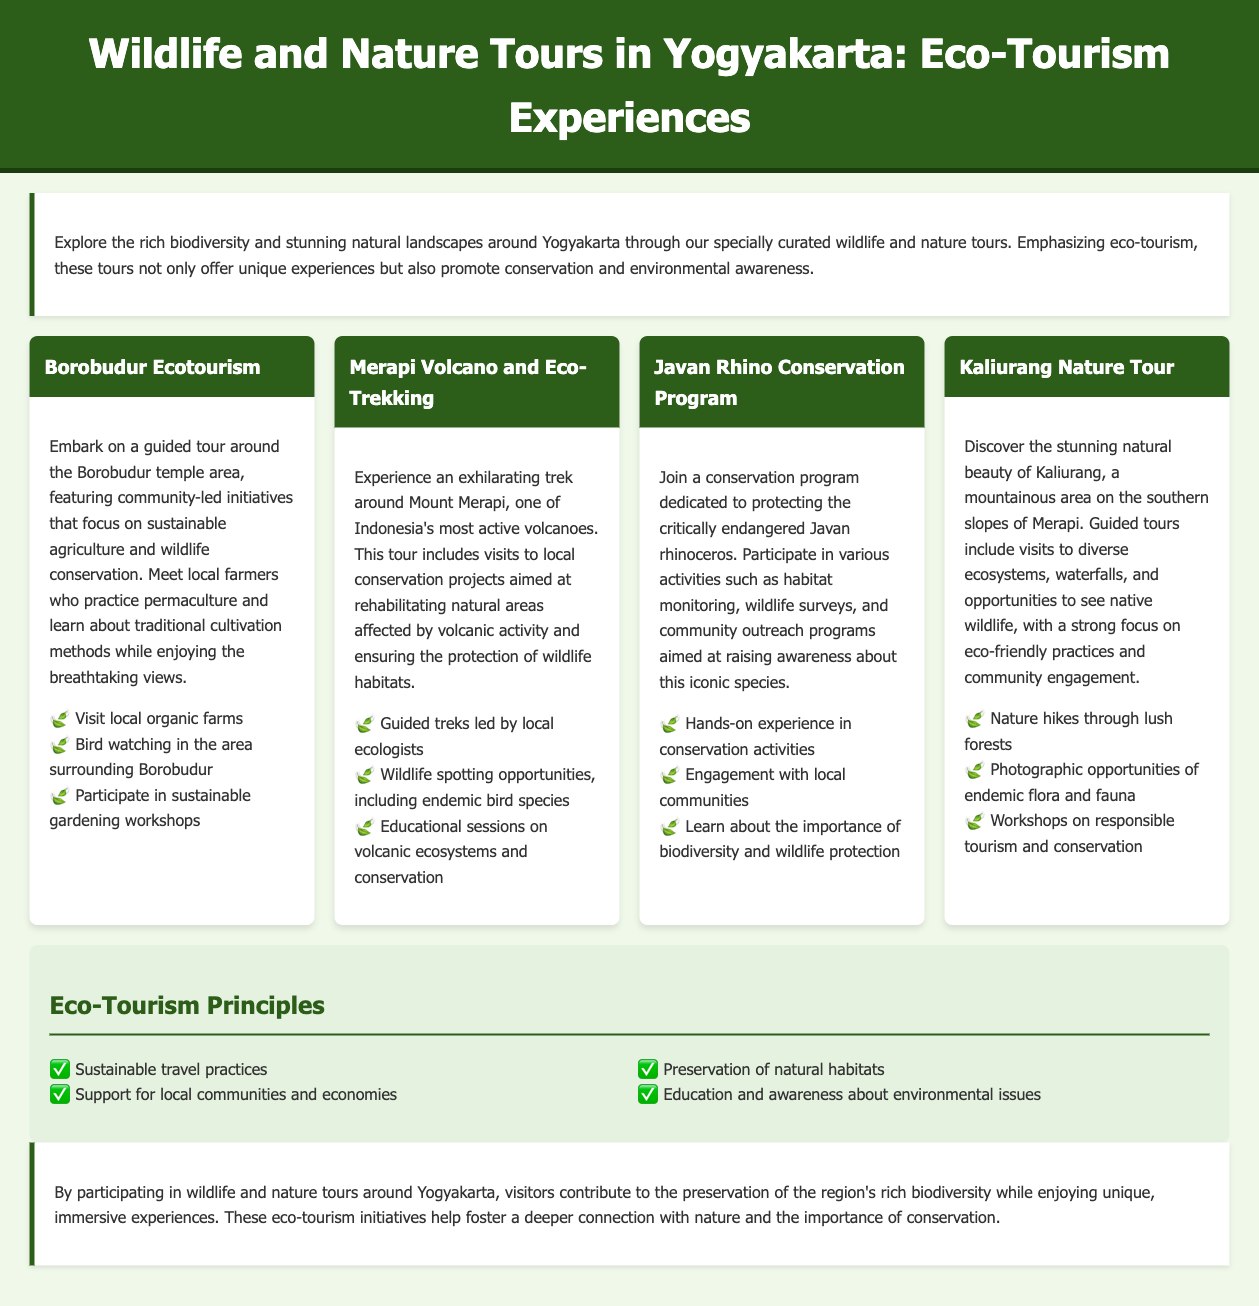What is the title of the document? The title of the document is found in the head section of the HTML code as specified in the title tag.
Answer: Wildlife and Nature Tours in Yogyakarta: Eco-Tourism Experiences How many tours are listed in the document? The tours can be counted in the tour-grid section, where each tour is represented by a tour card.
Answer: 4 What is the main focus of the tours? The main focus is highlighted in the introduction at the beginning of the document, emphasizing eco-tourism.
Answer: Eco-tourism Which volcano is featured in one of the tours? The specific volcano can be identified in the title of the tour that includes it.
Answer: Merapi What type of animal is the Javan Rhino classified as? This can be inferred from the title of the conservation program mentioned in the document.
Answer: Critically endangered What are participants encouraged to learn about in the Kaliurang Nature Tour? The information can be located in the tour description focusing on key activities or themes.
Answer: Responsible tourism and conservation Name one of the eco-tourism principles mentioned in the document. These principles are listed in the eco-tourism principles section, detailing the key values promoted.
Answer: Sustainable travel practices What type of activities are included in the Javan Rhino Conservation Program? This can be derived from the description of the program highlighting participant engagement.
Answer: Habitat monitoring, wildlife surveys, and community outreach programs Which type of ecosystem experiences can visitors expect in the Kaliurang Nature Tour? The expected experiences are detailed in the description of the tour highlighting diversity in nature.
Answer: Diverse ecosystems 